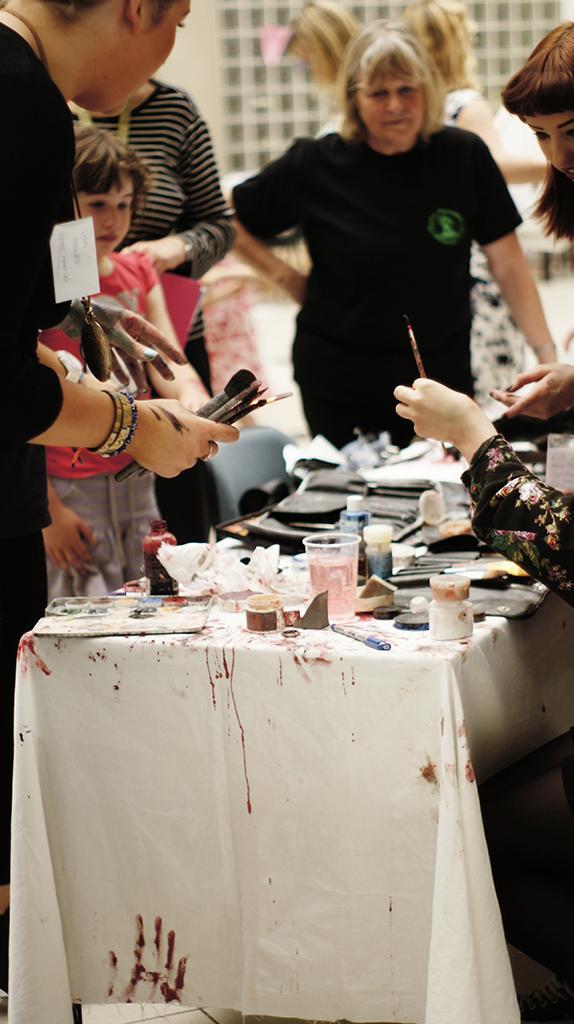In one or two sentences, can you explain what this image depicts? In this image we can see many people. Person on the left is wearing bracelets, badge and holding brushes. There is a table with a cloth. On the table there is a glass, pen, papers, bottles and many other items. In the background there is a building and it is looking blurred. 